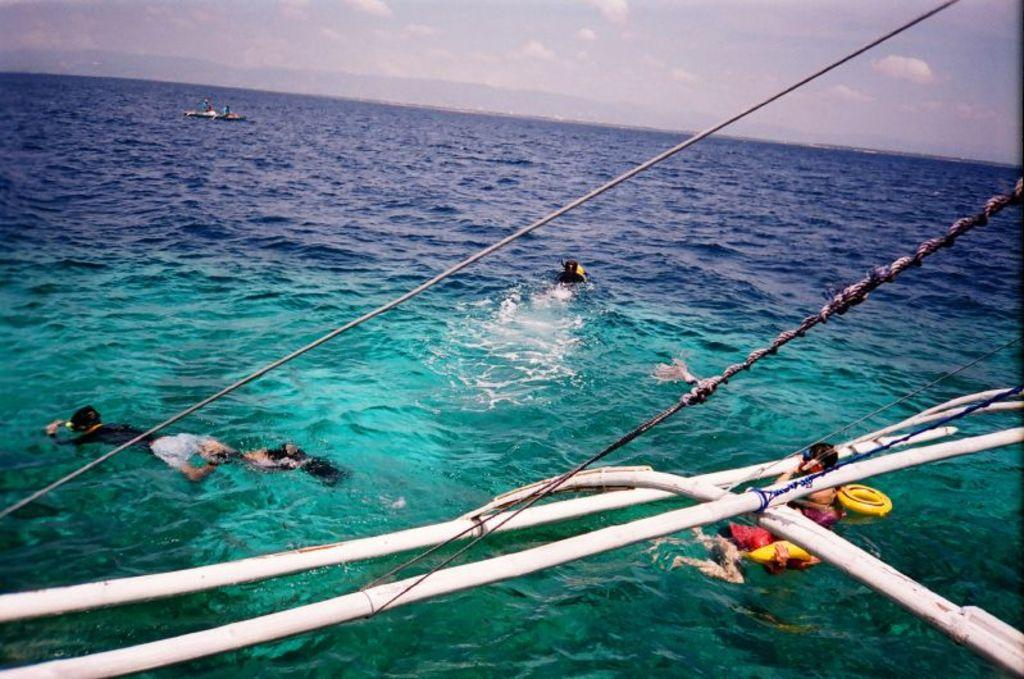What are the three people in the image doing? The three people in the image are swimming in the sea. What objects can be seen near the water's edge? There are two ropes tied to rods in the front. What can be seen in the distance on the water? There is a boat sailing on the water in the distance. Can you see any ants crawling on the people swimming in the image? There are no ants visible in the image; it features people swimming in the sea. 